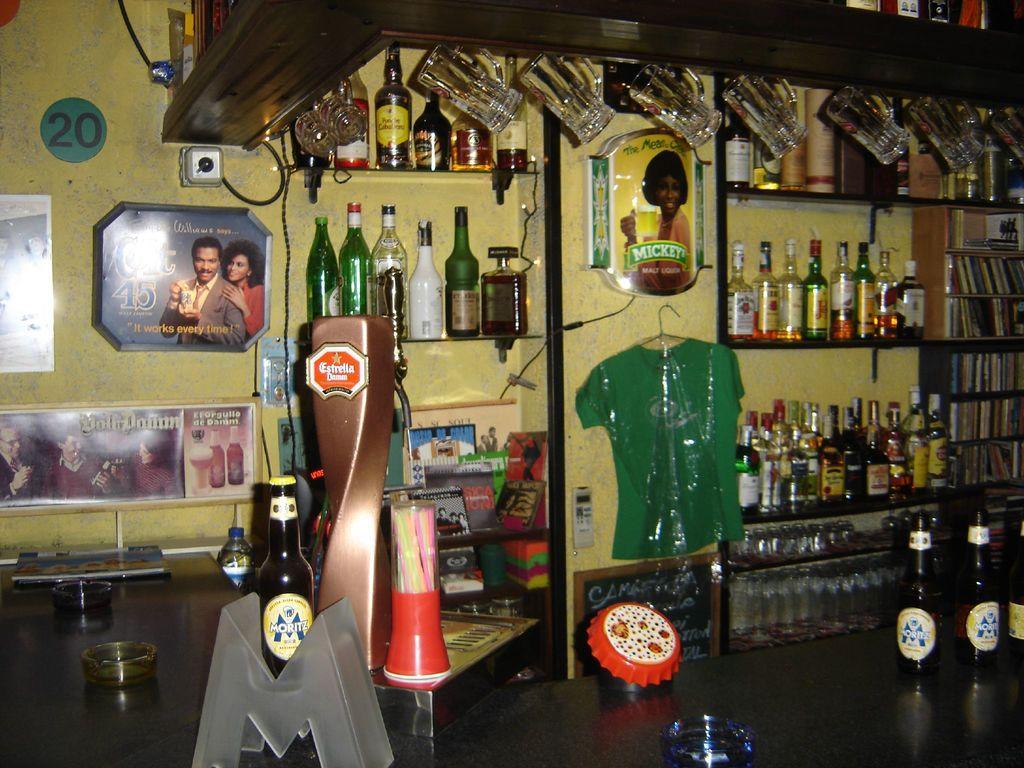How would you summarize this image in a sentence or two? In this image I can see many wine bottles in the rack. There is a green color t-shirt hanging to the wall. To the left there are frames and borders to the wall and I can see few books inside the rack. There are stickers can be seen to the wine bottles and there are many glasses on the top. 